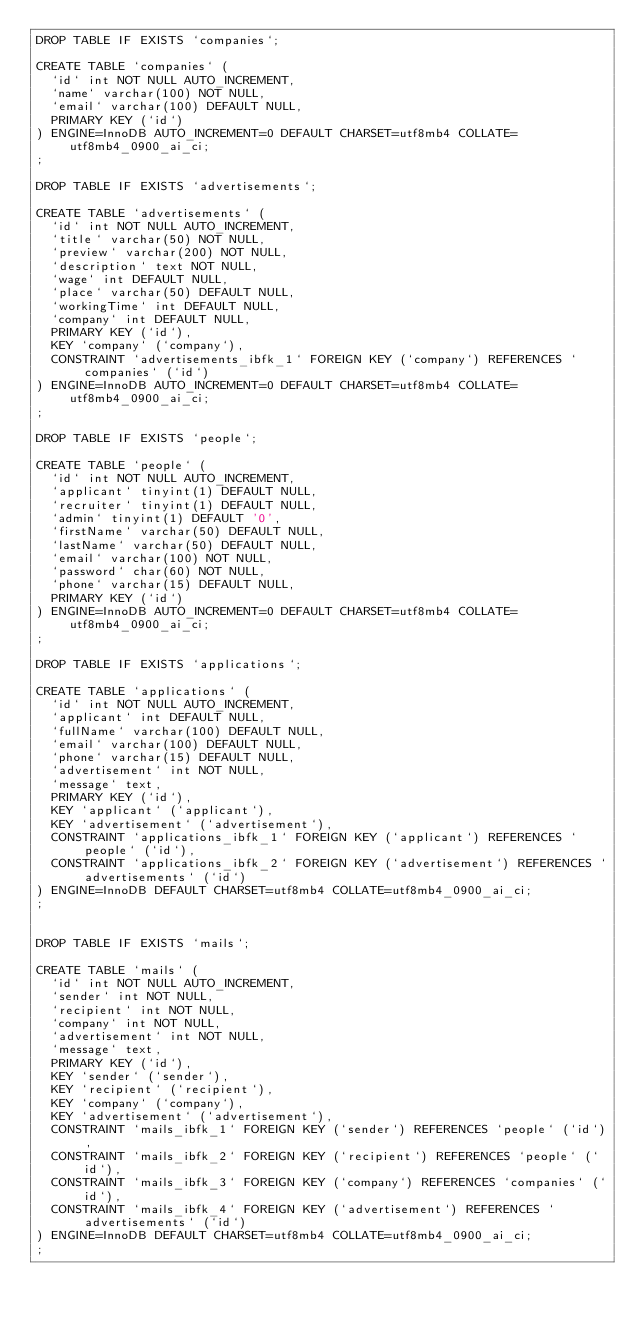<code> <loc_0><loc_0><loc_500><loc_500><_SQL_>DROP TABLE IF EXISTS `companies`;

CREATE TABLE `companies` (
  `id` int NOT NULL AUTO_INCREMENT,
  `name` varchar(100) NOT NULL,
  `email` varchar(100) DEFAULT NULL,
  PRIMARY KEY (`id`)
) ENGINE=InnoDB AUTO_INCREMENT=0 DEFAULT CHARSET=utf8mb4 COLLATE=utf8mb4_0900_ai_ci;
;

DROP TABLE IF EXISTS `advertisements`;

CREATE TABLE `advertisements` (
  `id` int NOT NULL AUTO_INCREMENT,
  `title` varchar(50) NOT NULL,
  `preview` varchar(200) NOT NULL,
  `description` text NOT NULL,
  `wage` int DEFAULT NULL,
  `place` varchar(50) DEFAULT NULL,
  `workingTime` int DEFAULT NULL,
  `company` int DEFAULT NULL,
  PRIMARY KEY (`id`),
  KEY `company` (`company`),
  CONSTRAINT `advertisements_ibfk_1` FOREIGN KEY (`company`) REFERENCES `companies` (`id`)
) ENGINE=InnoDB AUTO_INCREMENT=0 DEFAULT CHARSET=utf8mb4 COLLATE=utf8mb4_0900_ai_ci;
;

DROP TABLE IF EXISTS `people`;

CREATE TABLE `people` (
  `id` int NOT NULL AUTO_INCREMENT,
  `applicant` tinyint(1) DEFAULT NULL,
  `recruiter` tinyint(1) DEFAULT NULL,
  `admin` tinyint(1) DEFAULT '0',
  `firstName` varchar(50) DEFAULT NULL,
  `lastName` varchar(50) DEFAULT NULL,
  `email` varchar(100) NOT NULL,
  `password` char(60) NOT NULL,
  `phone` varchar(15) DEFAULT NULL,
  PRIMARY KEY (`id`)
) ENGINE=InnoDB AUTO_INCREMENT=0 DEFAULT CHARSET=utf8mb4 COLLATE=utf8mb4_0900_ai_ci;
;

DROP TABLE IF EXISTS `applications`;

CREATE TABLE `applications` (
  `id` int NOT NULL AUTO_INCREMENT,
  `applicant` int DEFAULT NULL,
  `fullName` varchar(100) DEFAULT NULL,
  `email` varchar(100) DEFAULT NULL,
  `phone` varchar(15) DEFAULT NULL,
  `advertisement` int NOT NULL,
  `message` text,
  PRIMARY KEY (`id`),
  KEY `applicant` (`applicant`),
  KEY `advertisement` (`advertisement`),
  CONSTRAINT `applications_ibfk_1` FOREIGN KEY (`applicant`) REFERENCES `people` (`id`),
  CONSTRAINT `applications_ibfk_2` FOREIGN KEY (`advertisement`) REFERENCES `advertisements` (`id`)
) ENGINE=InnoDB DEFAULT CHARSET=utf8mb4 COLLATE=utf8mb4_0900_ai_ci;
;


DROP TABLE IF EXISTS `mails`;

CREATE TABLE `mails` (
  `id` int NOT NULL AUTO_INCREMENT,
  `sender` int NOT NULL,
  `recipient` int NOT NULL,
  `company` int NOT NULL,
  `advertisement` int NOT NULL,
  `message` text,
  PRIMARY KEY (`id`),
  KEY `sender` (`sender`),
  KEY `recipient` (`recipient`),
  KEY `company` (`company`),
  KEY `advertisement` (`advertisement`),
  CONSTRAINT `mails_ibfk_1` FOREIGN KEY (`sender`) REFERENCES `people` (`id`),
  CONSTRAINT `mails_ibfk_2` FOREIGN KEY (`recipient`) REFERENCES `people` (`id`),
  CONSTRAINT `mails_ibfk_3` FOREIGN KEY (`company`) REFERENCES `companies` (`id`),
  CONSTRAINT `mails_ibfk_4` FOREIGN KEY (`advertisement`) REFERENCES `advertisements` (`id`)
) ENGINE=InnoDB DEFAULT CHARSET=utf8mb4 COLLATE=utf8mb4_0900_ai_ci;
;
</code> 